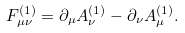<formula> <loc_0><loc_0><loc_500><loc_500>F _ { \mu \nu } ^ { ( 1 ) } = \partial _ { \mu } A _ { \nu } ^ { ( 1 ) } - \partial _ { \nu } A _ { \mu } ^ { ( 1 ) } .</formula> 